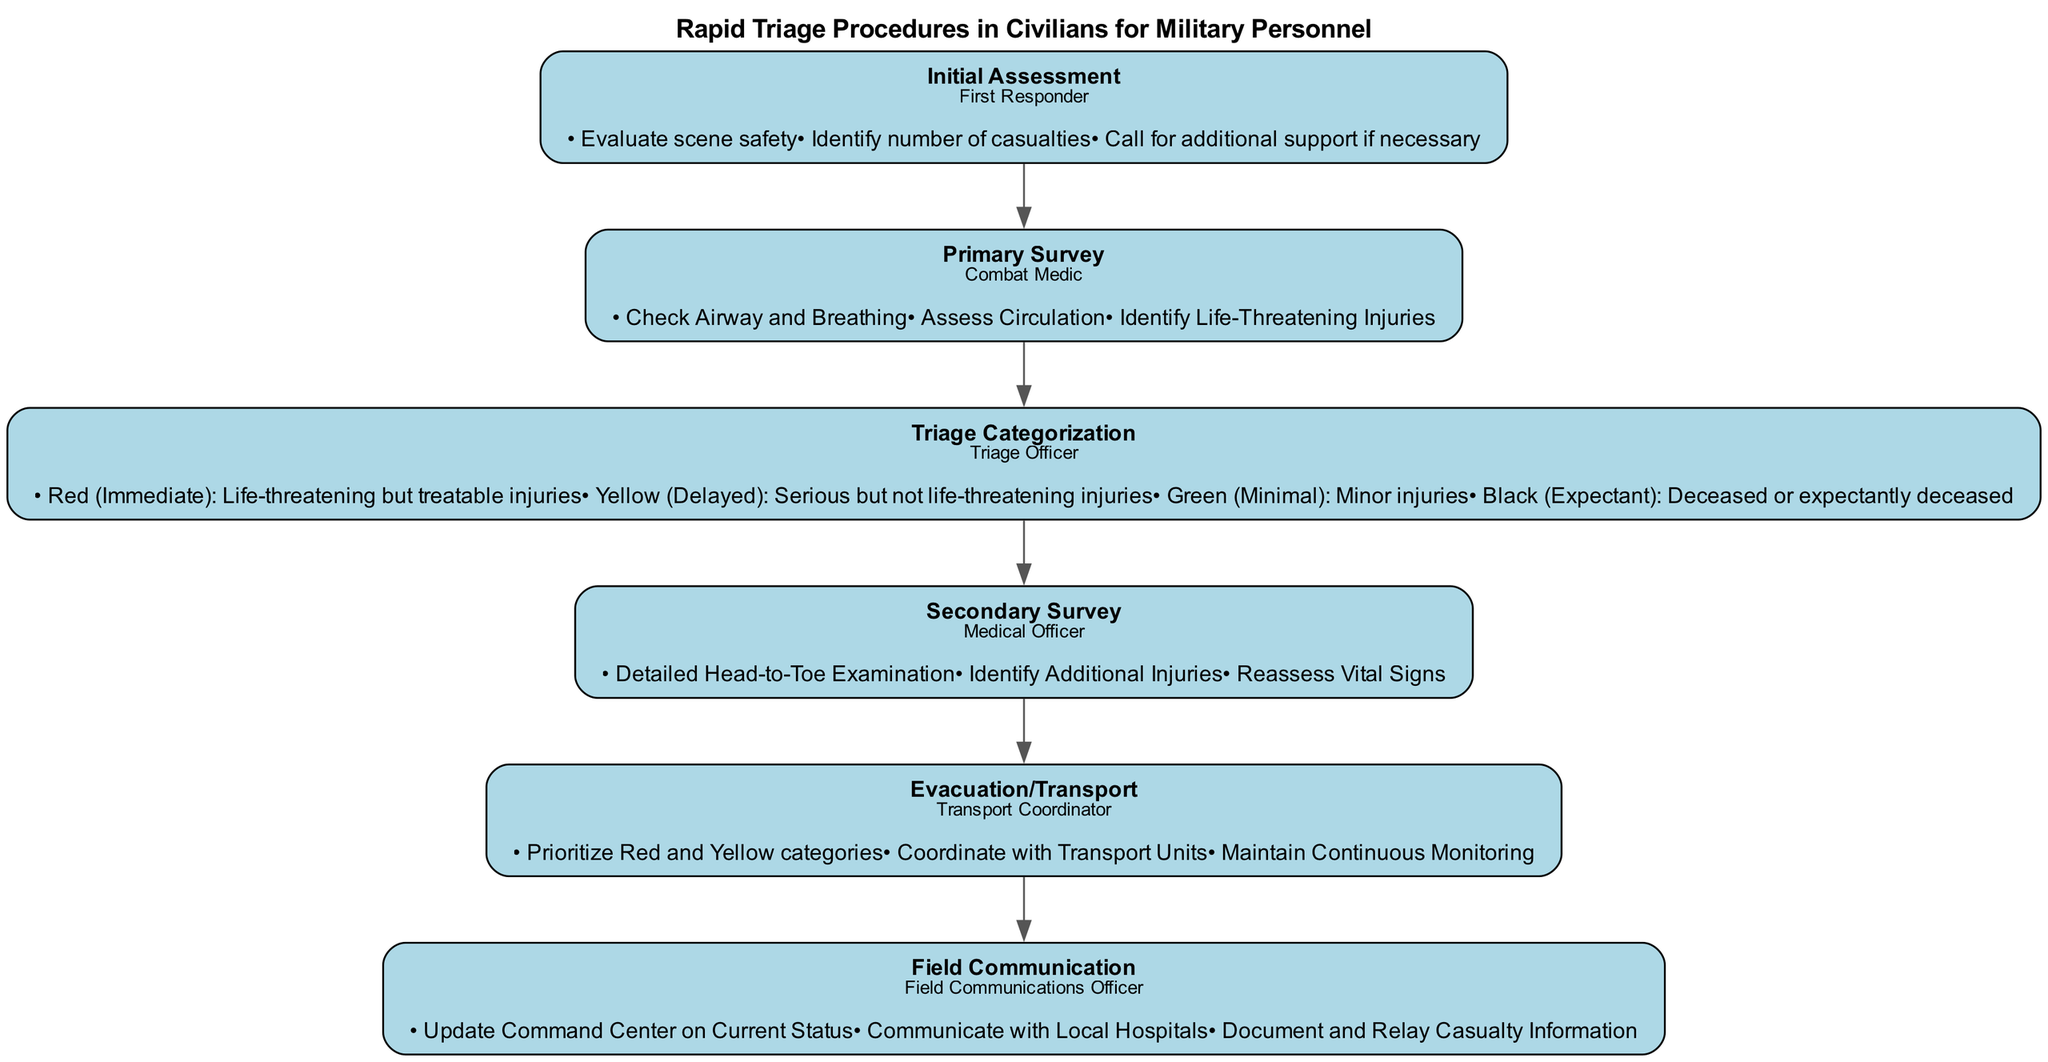What is the first step in the clinical pathway? The first step listed in the diagram is "Initial Assessment." This is identified as the first step when reviewing the sequence of steps in the clinical pathway.
Answer: Initial Assessment Who is responsible for the "Primary Survey"? The responsible personnel for the "Primary Survey" step is a "Combat Medic." This can be seen in the responsible personnel section of the corresponding step in the diagram.
Answer: Combat Medic How many triage categories are there? The diagram lists four triage categories: Red, Yellow, Green, and Black. Counting these categories gives a total of four.
Answer: 4 What are the procedures for the "Evacuation/Transport" step? The procedures listed for the "Evacuation/Transport" step include: "Prioritize Red and Yellow categories," "Coordinate with Transport Units," and "Maintain Continuous Monitoring." They can be found under the procedures of that specific step in the diagram.
Answer: Prioritize Red and Yellow categories, Coordinate with Transport Units, Maintain Continuous Monitoring Which step comes after the "Triage Categorization"? The step that follows "Triage Categorization" is "Secondary Survey." This can be determined by examining the flow of steps in the diagram from one to the next.
Answer: Secondary Survey What type of injuries are categorized under "Yellow"? Injuries classified under "Yellow" in the triage categorization are described as "Serious but not life-threatening injuries." This description is stated in the procedures for that category in the diagram.
Answer: Serious but not life-threatening injuries What action is taken during the "Field Communication" step? During "Field Communication," one of the actions taken is to "Update Command Center on Current Status." This action is found specifically in the procedures of that step.
Answer: Update Command Center on Current Status Who coordinates the "Evacuation/Transport"? The "Transport Coordinator" is responsible for coordinating the "Evacuation/Transport." This is clearly stated in the responsible personnel section of that step in the diagram.
Answer: Transport Coordinator 